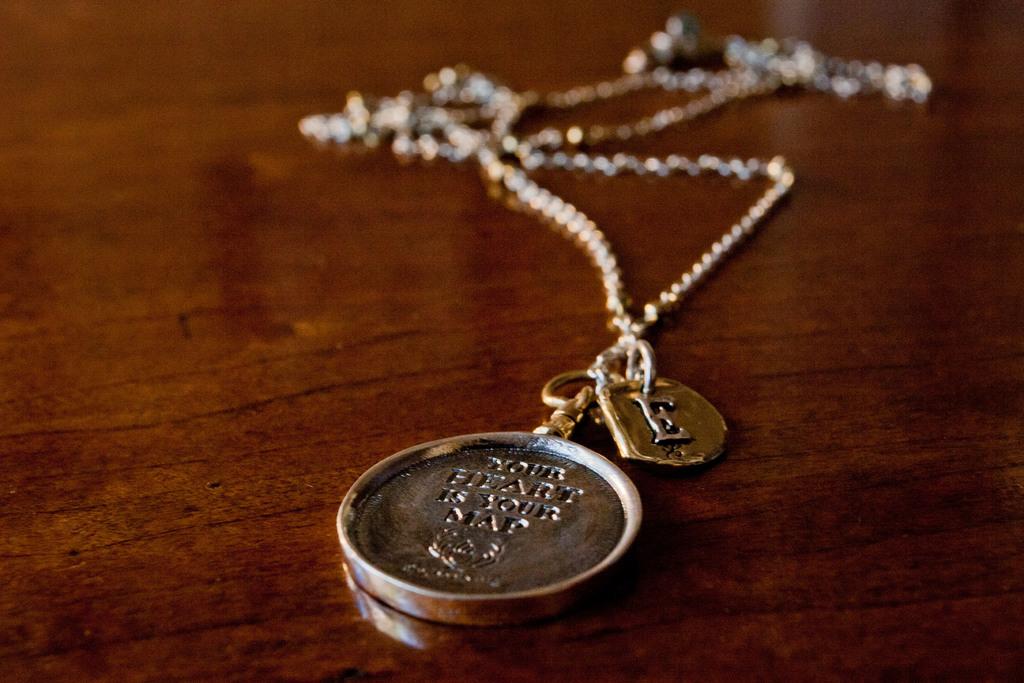What is your heart?
Provide a short and direct response. Your map. What chain is that?
Provide a short and direct response. Your heart is your map. 